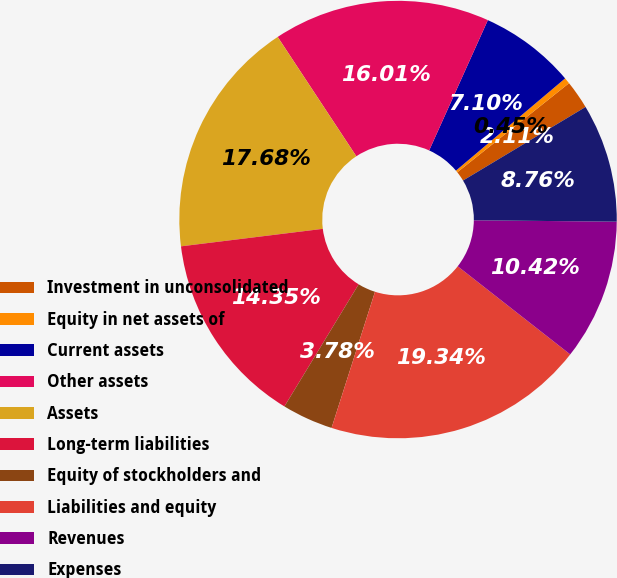Convert chart to OTSL. <chart><loc_0><loc_0><loc_500><loc_500><pie_chart><fcel>Investment in unconsolidated<fcel>Equity in net assets of<fcel>Current assets<fcel>Other assets<fcel>Assets<fcel>Long-term liabilities<fcel>Equity of stockholders and<fcel>Liabilities and equity<fcel>Revenues<fcel>Expenses<nl><fcel>2.11%<fcel>0.45%<fcel>7.1%<fcel>16.01%<fcel>17.68%<fcel>14.35%<fcel>3.78%<fcel>19.34%<fcel>10.42%<fcel>8.76%<nl></chart> 